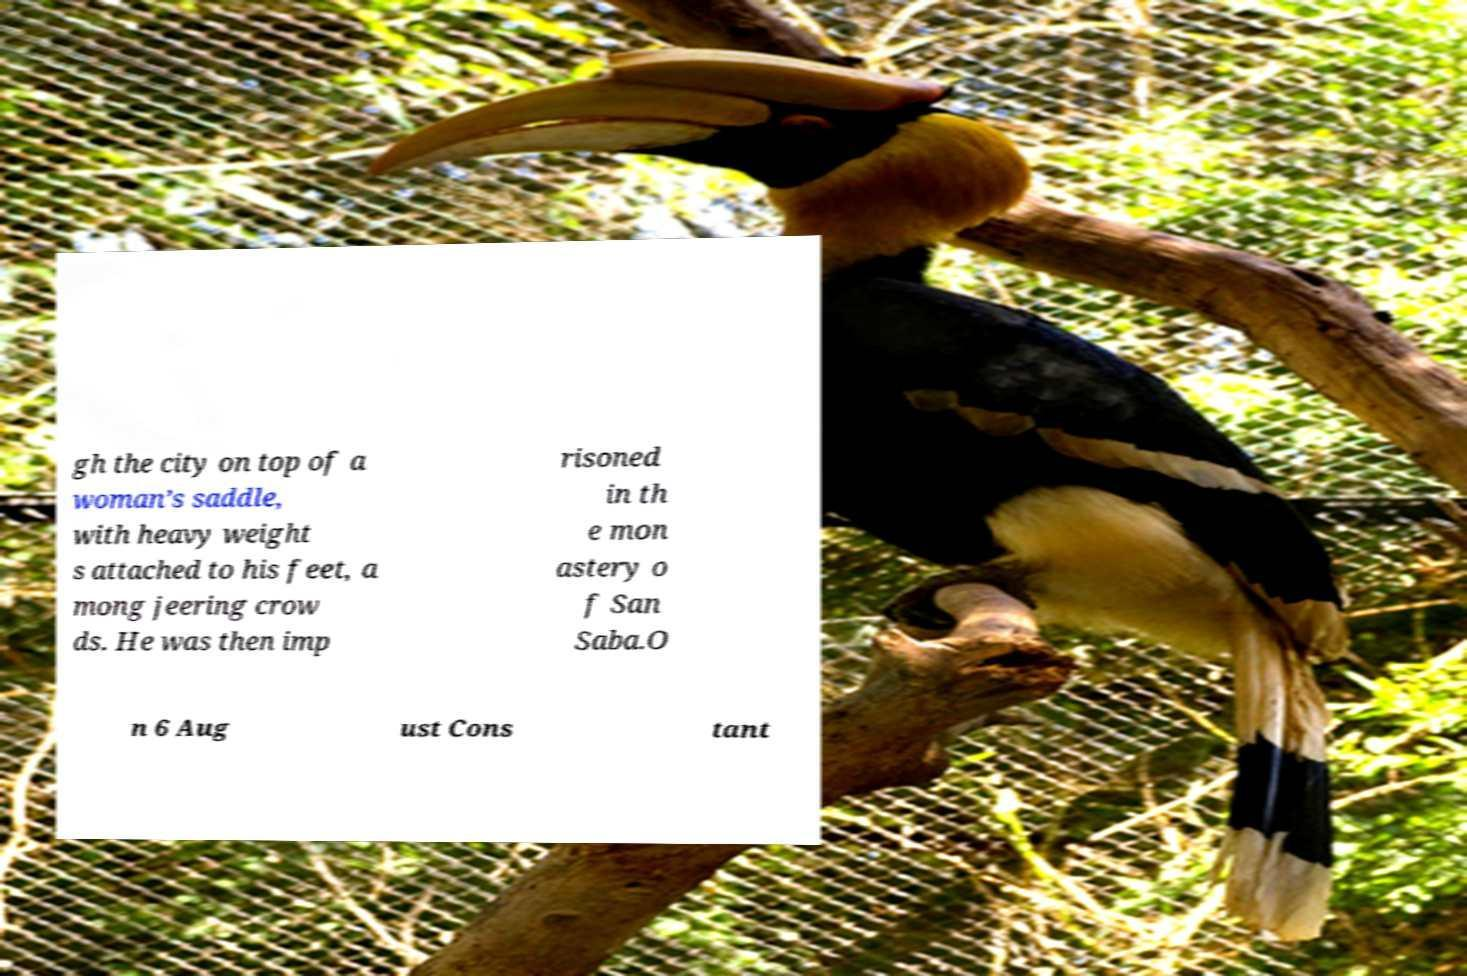Could you assist in decoding the text presented in this image and type it out clearly? gh the city on top of a woman’s saddle, with heavy weight s attached to his feet, a mong jeering crow ds. He was then imp risoned in th e mon astery o f San Saba.O n 6 Aug ust Cons tant 